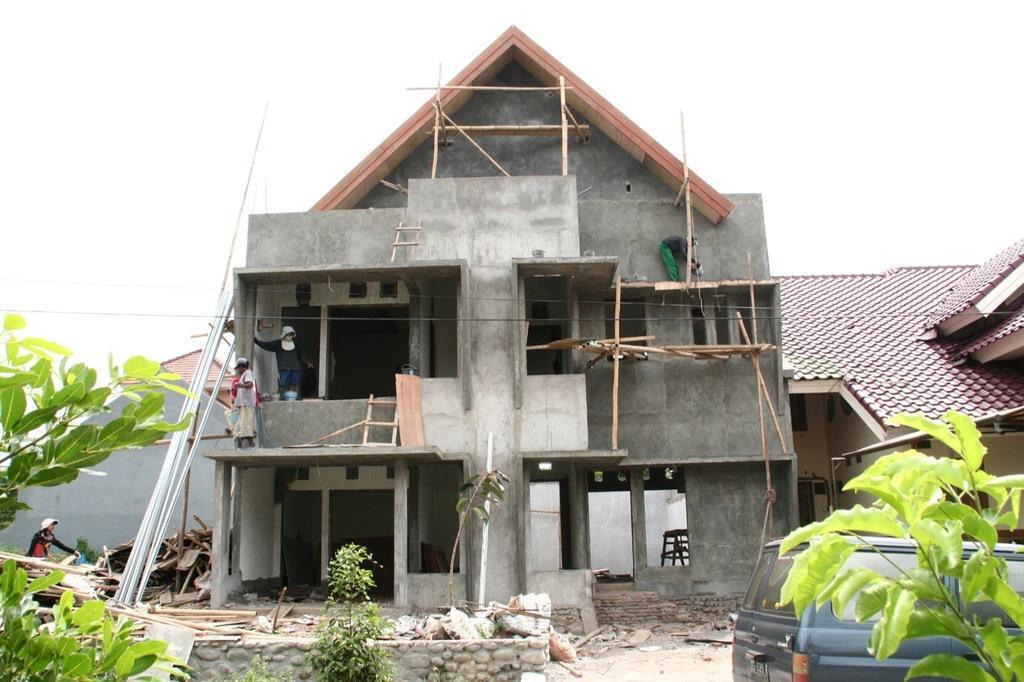In one or two sentences, can you explain what this image depicts? In this image I can see few buildings, plants, vehicle, few people, wooden logs, few objects and the sky. 